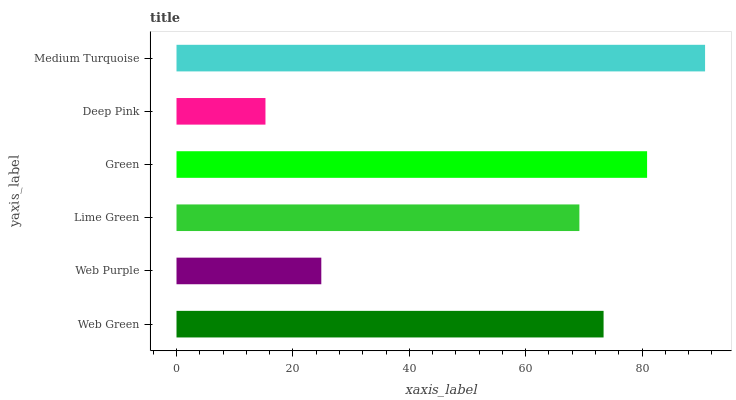Is Deep Pink the minimum?
Answer yes or no. Yes. Is Medium Turquoise the maximum?
Answer yes or no. Yes. Is Web Purple the minimum?
Answer yes or no. No. Is Web Purple the maximum?
Answer yes or no. No. Is Web Green greater than Web Purple?
Answer yes or no. Yes. Is Web Purple less than Web Green?
Answer yes or no. Yes. Is Web Purple greater than Web Green?
Answer yes or no. No. Is Web Green less than Web Purple?
Answer yes or no. No. Is Web Green the high median?
Answer yes or no. Yes. Is Lime Green the low median?
Answer yes or no. Yes. Is Green the high median?
Answer yes or no. No. Is Web Purple the low median?
Answer yes or no. No. 